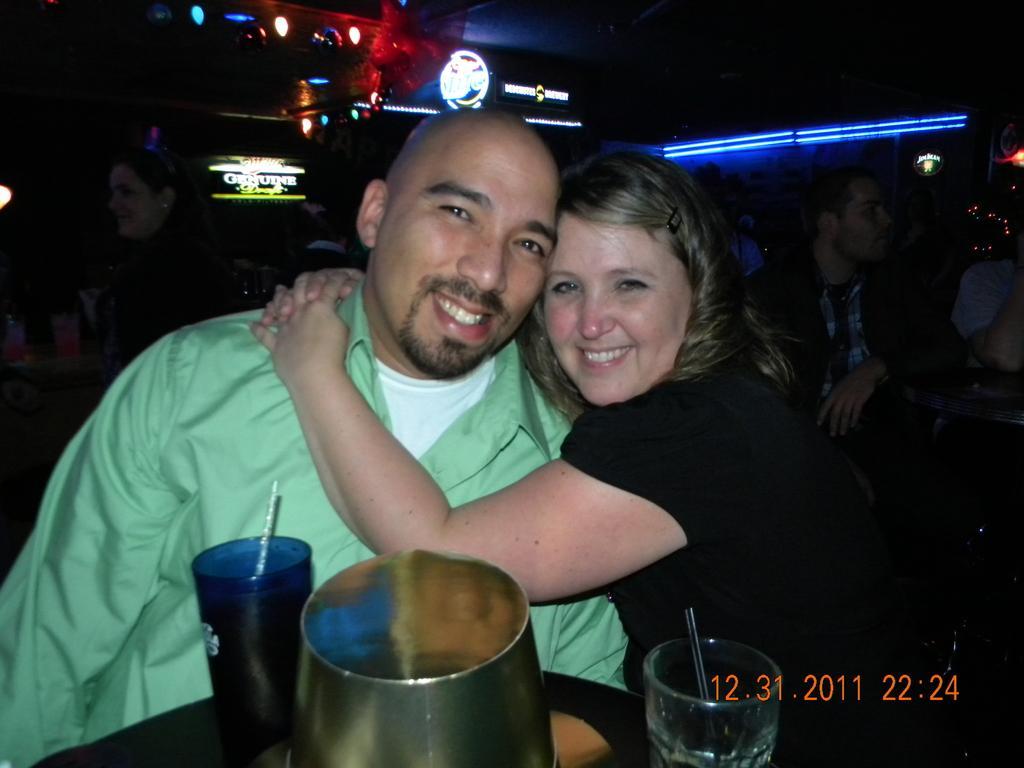Can you describe this image briefly? This picture shows few people seated and we see a woman holding a man and we see couple of glasses with straws and a jug on the table and we see lights and we see date and time at the bottom corner of the picture. 